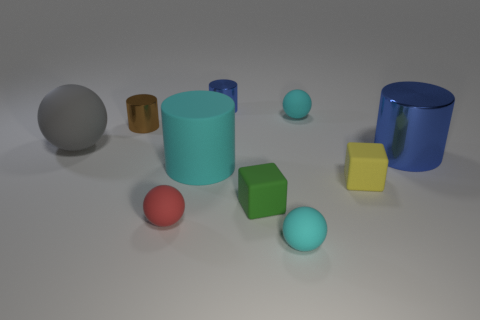Subtract all matte cylinders. How many cylinders are left? 3 Subtract all cyan spheres. How many spheres are left? 2 Subtract all blocks. How many objects are left? 8 Subtract all gray balls. Subtract all purple cylinders. How many balls are left? 3 Subtract all brown blocks. How many cyan balls are left? 2 Subtract all cyan balls. Subtract all tiny matte spheres. How many objects are left? 5 Add 4 large metallic cylinders. How many large metallic cylinders are left? 5 Add 10 purple spheres. How many purple spheres exist? 10 Subtract 0 yellow cylinders. How many objects are left? 10 Subtract 2 cylinders. How many cylinders are left? 2 